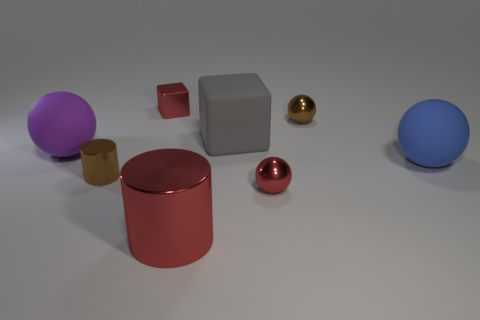Subtract all purple spheres. How many spheres are left? 3 Add 1 small metal things. How many objects exist? 9 Subtract all purple spheres. How many spheres are left? 3 Subtract 2 balls. How many balls are left? 2 Subtract all cubes. How many objects are left? 6 Subtract all red cubes. Subtract all green cylinders. How many cubes are left? 1 Subtract all purple things. Subtract all balls. How many objects are left? 3 Add 1 rubber objects. How many rubber objects are left? 4 Add 8 blue spheres. How many blue spheres exist? 9 Subtract 0 purple blocks. How many objects are left? 8 